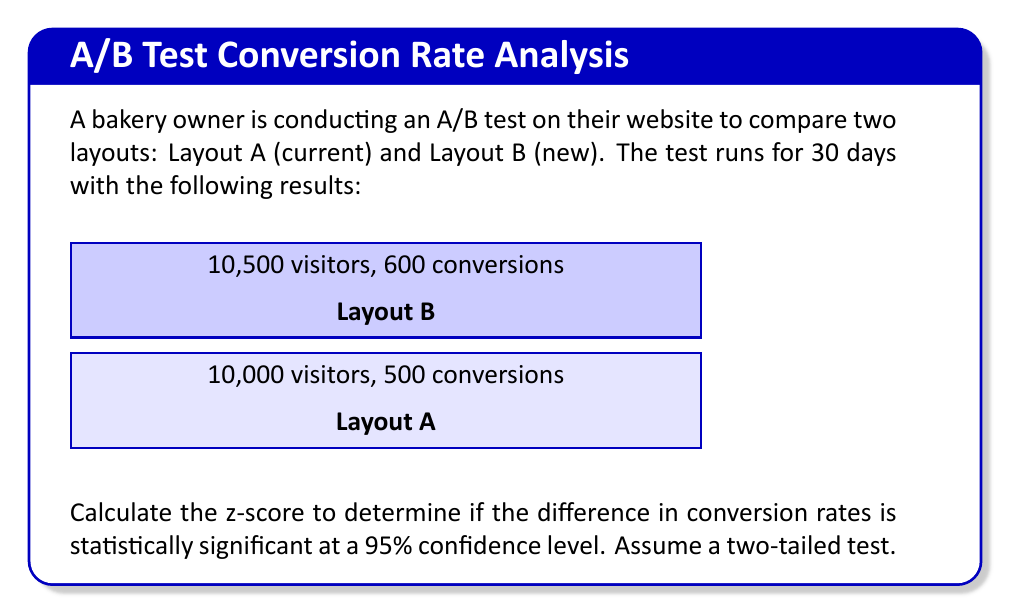What is the answer to this math problem? To calculate the z-score for this A/B test, we'll follow these steps:

1. Calculate conversion rates for both layouts:
   Layout A: $p_A = \frac{500}{10000} = 0.05$ or 5%
   Layout B: $p_B = \frac{600}{10500} \approx 0.0571$ or 5.71%

2. Calculate the pooled conversion rate:
   $$p = \frac{500 + 600}{10000 + 10500} \approx 0.0536$$

3. Calculate the standard error of the difference:
   $$SE = \sqrt{p(1-p)(\frac{1}{n_A} + \frac{1}{n_B})}$$
   $$SE = \sqrt{0.0536(1-0.0536)(\frac{1}{10000} + \frac{1}{10500})} \approx 0.00315$$

4. Calculate the z-score:
   $$z = \frac{p_B - p_A}{SE} = \frac{0.0571 - 0.05}{0.00315} \approx 2.254$$

5. Determine statistical significance:
   For a 95% confidence level in a two-tailed test, the critical z-value is ±1.96.
   Since our calculated z-score (2.254) is greater than 1.96, the difference is statistically significant.
Answer: $z \approx 2.254$ 